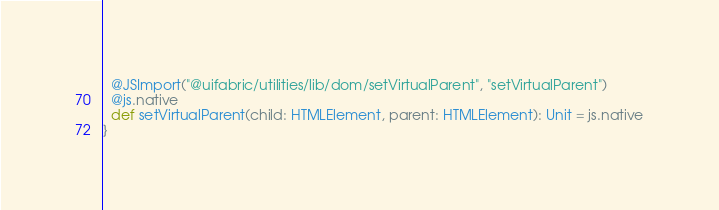Convert code to text. <code><loc_0><loc_0><loc_500><loc_500><_Scala_>  @JSImport("@uifabric/utilities/lib/dom/setVirtualParent", "setVirtualParent")
  @js.native
  def setVirtualParent(child: HTMLElement, parent: HTMLElement): Unit = js.native
}
</code> 